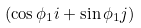<formula> <loc_0><loc_0><loc_500><loc_500>( \cos { \phi _ { 1 } } { i } + \sin { \phi _ { 1 } } { j } )</formula> 